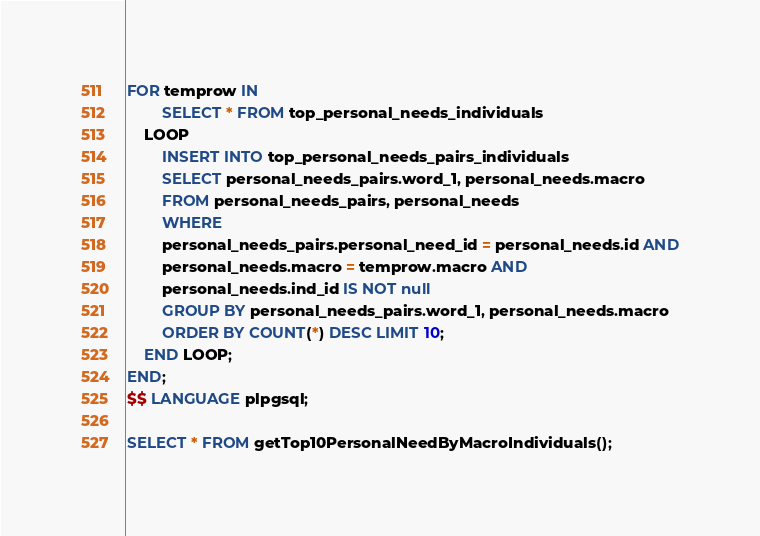<code> <loc_0><loc_0><loc_500><loc_500><_SQL_>FOR temprow IN
        SELECT * FROM top_personal_needs_individuals
    LOOP
        INSERT INTO top_personal_needs_pairs_individuals
        SELECT personal_needs_pairs.word_1, personal_needs.macro
        FROM personal_needs_pairs, personal_needs
        WHERE 
        personal_needs_pairs.personal_need_id = personal_needs.id AND
        personal_needs.macro = temprow.macro AND
        personal_needs.ind_id IS NOT null
        GROUP BY personal_needs_pairs.word_1, personal_needs.macro
        ORDER BY COUNT(*) DESC LIMIT 10;
    END LOOP;
END;
$$ LANGUAGE plpgsql;

SELECT * FROM getTop10PersonalNeedByMacroIndividuals();</code> 